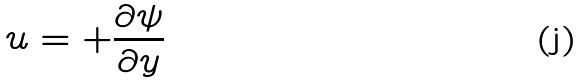<formula> <loc_0><loc_0><loc_500><loc_500>u = + \frac { \partial \psi } { \partial y }</formula> 